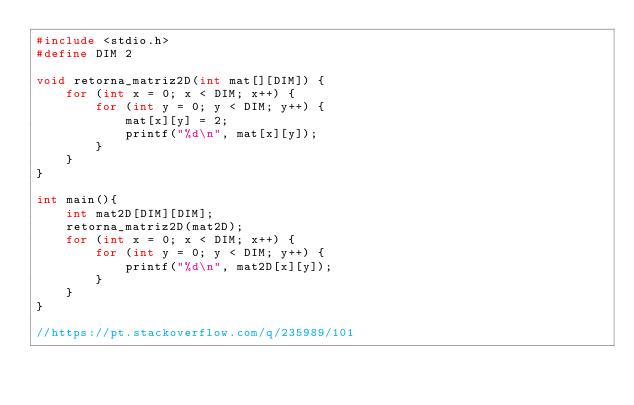Convert code to text. <code><loc_0><loc_0><loc_500><loc_500><_C_>#include <stdio.h>
#define DIM 2

void retorna_matriz2D(int mat[][DIM]) {
    for (int x = 0; x < DIM; x++) {
        for (int y = 0; y < DIM; y++) {
            mat[x][y] = 2;
            printf("%d\n", mat[x][y]);
        }
    }
}

int main(){
    int mat2D[DIM][DIM];
    retorna_matriz2D(mat2D);
    for (int x = 0; x < DIM; x++) {
        for (int y = 0; y < DIM; y++) {
            printf("%d\n", mat2D[x][y]);
        }
    }
}

//https://pt.stackoverflow.com/q/235989/101
</code> 